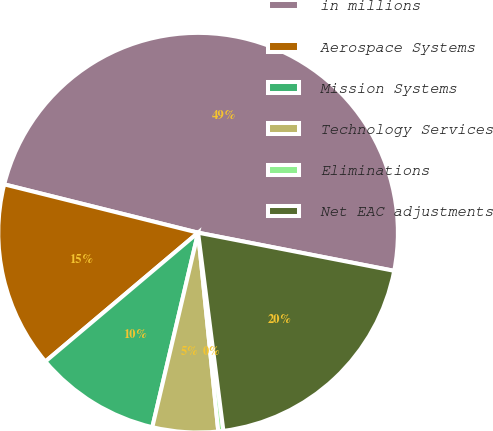Convert chart to OTSL. <chart><loc_0><loc_0><loc_500><loc_500><pie_chart><fcel>in millions<fcel>Aerospace Systems<fcel>Mission Systems<fcel>Technology Services<fcel>Eliminations<fcel>Net EAC adjustments<nl><fcel>49.17%<fcel>15.04%<fcel>10.17%<fcel>5.29%<fcel>0.41%<fcel>19.92%<nl></chart> 